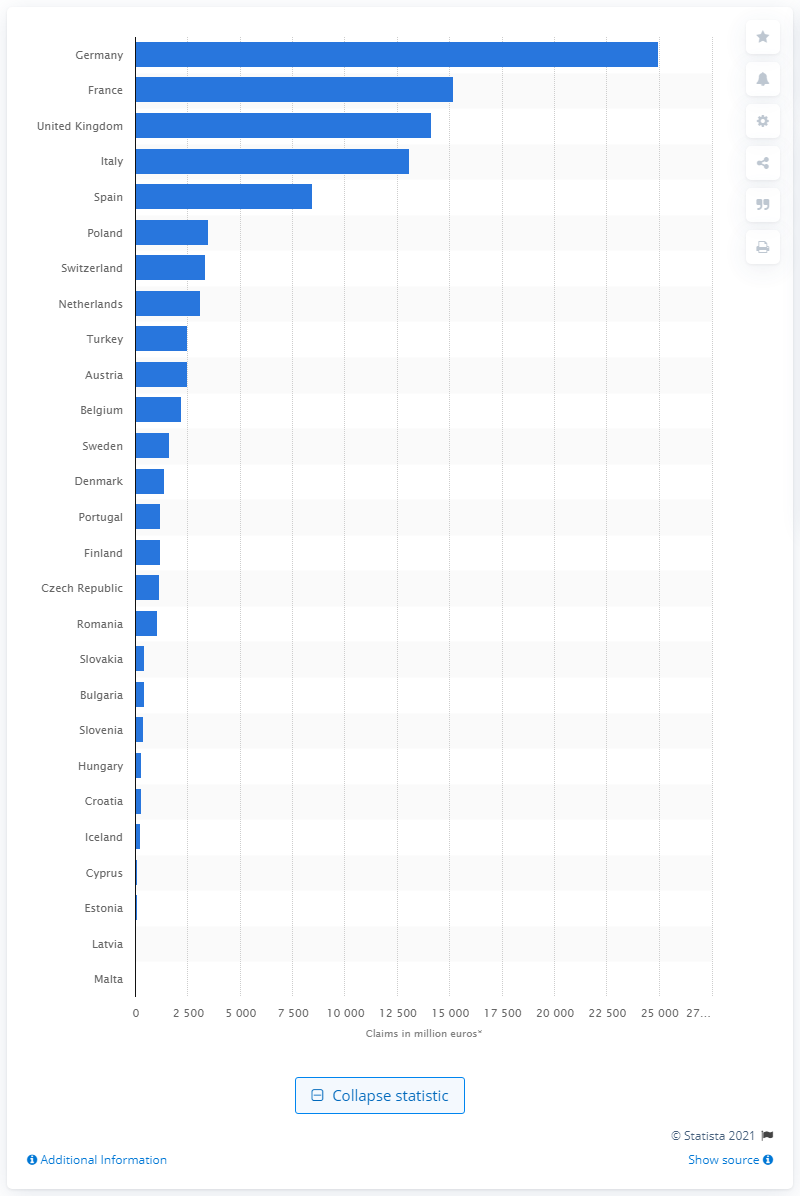List a handful of essential elements in this visual. According to the data available, the total amount of motor insurance claims paid out by insurance providers in Germany in 2019 was 24,968. 